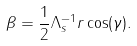<formula> <loc_0><loc_0><loc_500><loc_500>\beta = \frac { 1 } { 2 } \Lambda _ { s } ^ { - 1 } r \cos ( \gamma ) .</formula> 